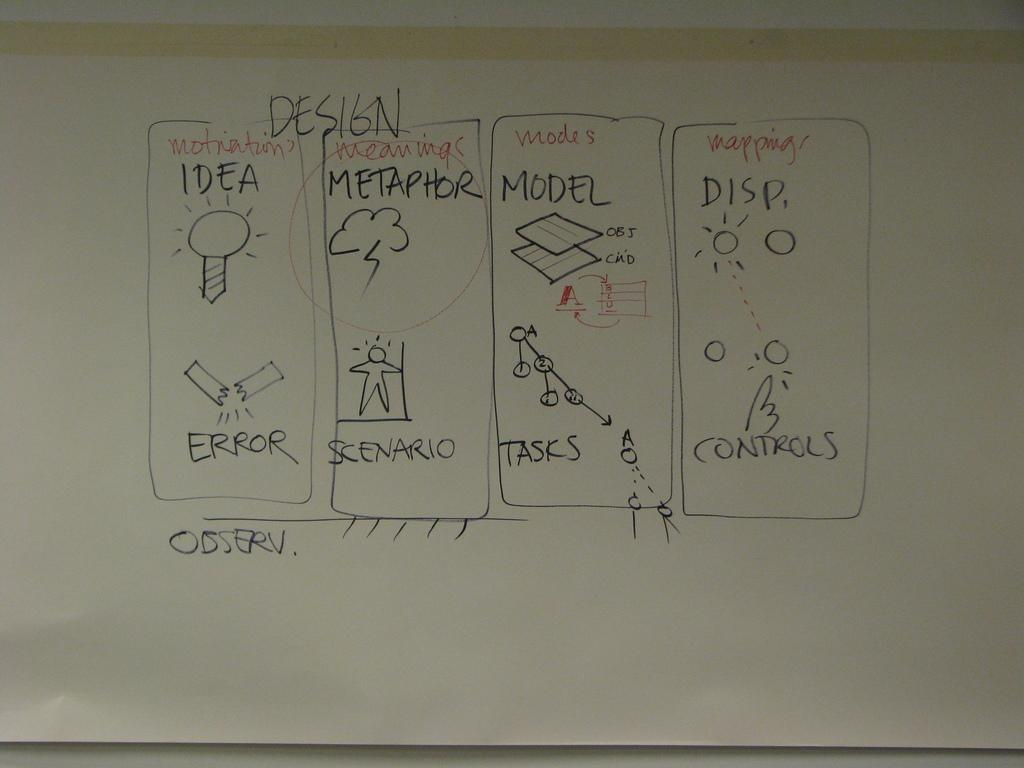<image>
Summarize the visual content of the image. A board that says Design has sections for ideas, metaphors, and models. 